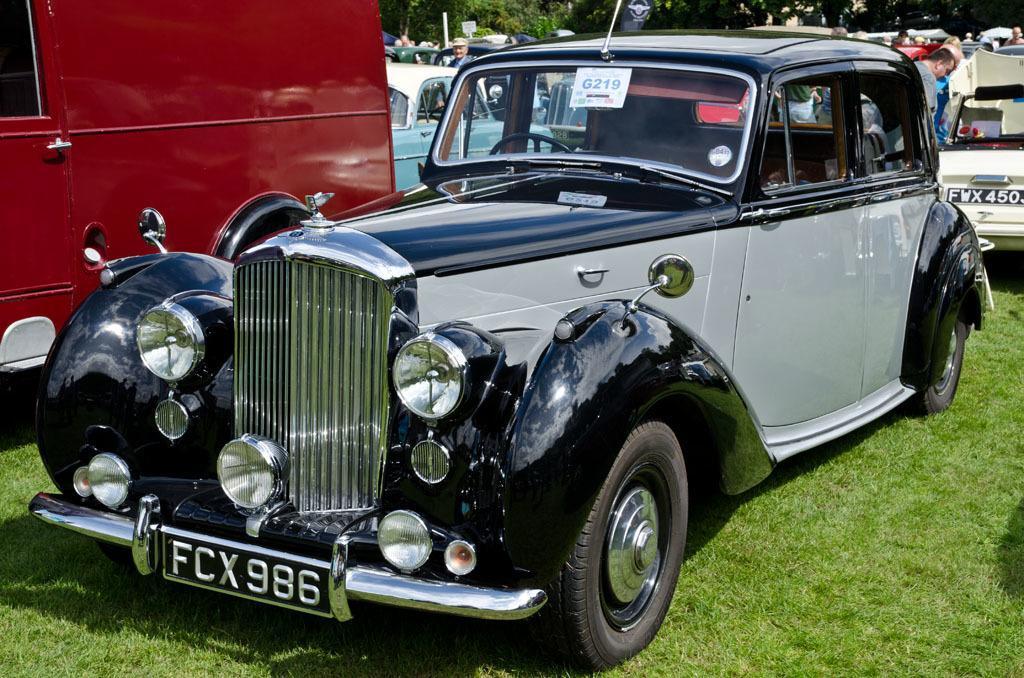How would you summarize this image in a sentence or two? In this image, we can see a car is parked on the grass. Background we can see vehicles, people, few objects and trees. 